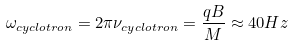Convert formula to latex. <formula><loc_0><loc_0><loc_500><loc_500>\omega _ { c y c l o t r o n } = 2 \pi \nu _ { c y c l o t r o n } = \frac { q B } { M } \approx 4 0 H z</formula> 